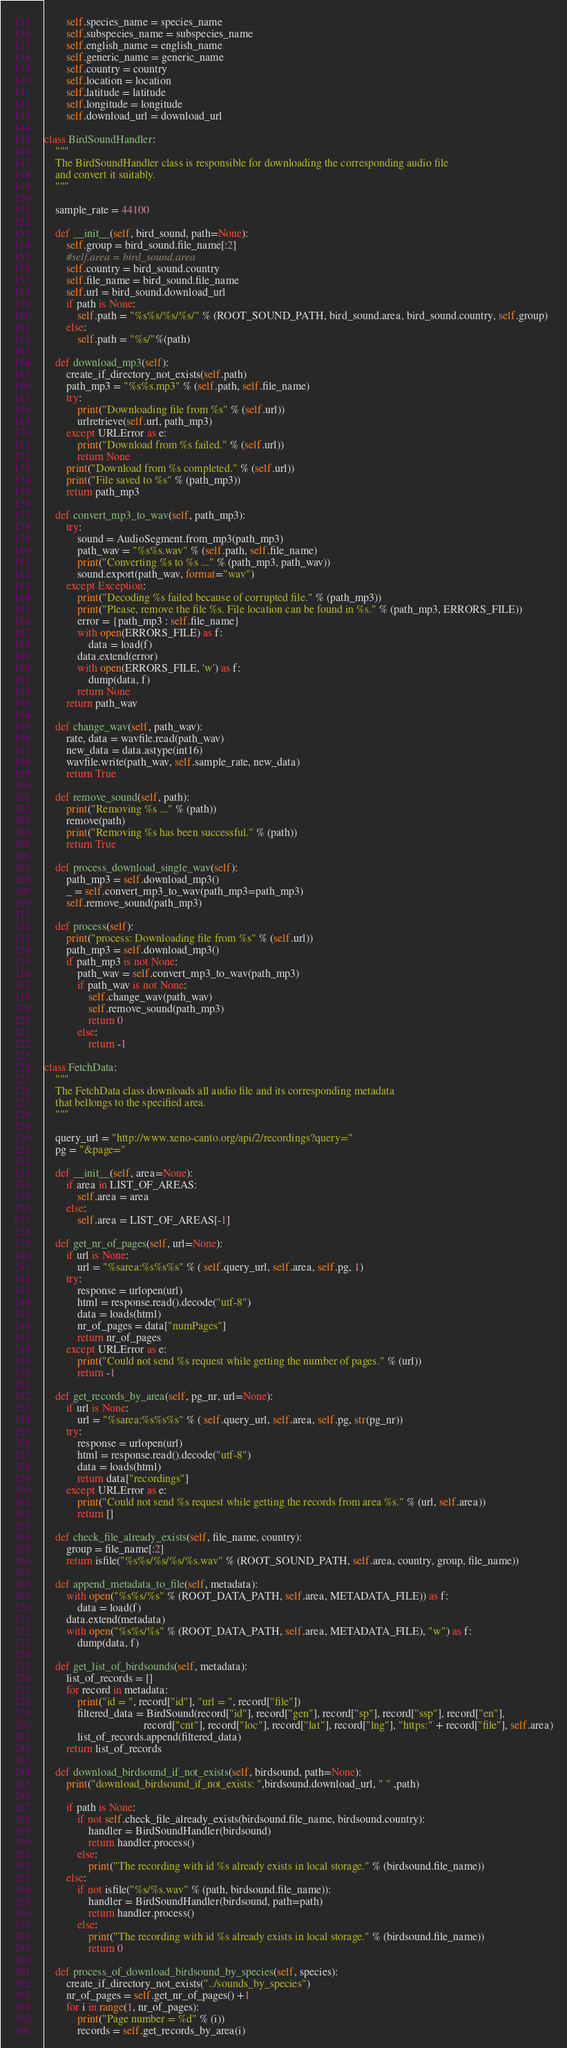<code> <loc_0><loc_0><loc_500><loc_500><_Python_>        self.species_name = species_name
        self.subspecies_name = subspecies_name
        self.english_name = english_name
        self.generic_name = generic_name
        self.country = country
        self.location = location
        self.latitude = latitude
        self.longitude = longitude
        self.download_url = download_url

class BirdSoundHandler:
    """
    The BirdSoundHandler class is responsible for downloading the corresponding audio file
    and convert it suitably.
    """

    sample_rate = 44100

    def __init__(self, bird_sound, path=None):
        self.group = bird_sound.file_name[:2]
        #self.area = bird_sound.area
        self.country = bird_sound.country
        self.file_name = bird_sound.file_name
        self.url = bird_sound.download_url
        if path is None:
            self.path = "%s%s/%s/%s/" % (ROOT_SOUND_PATH, bird_sound.area, bird_sound.country, self.group)
        else:
            self.path = "%s/"%(path)

    def download_mp3(self):
        create_if_directory_not_exists(self.path)
        path_mp3 = "%s%s.mp3" % (self.path, self.file_name)
        try:
            print("Downloading file from %s" % (self.url))
            urlretrieve(self.url, path_mp3)
        except URLError as e:
            print("Download from %s failed." % (self.url))
            return None
        print("Download from %s completed." % (self.url))
        print("File saved to %s" % (path_mp3))
        return path_mp3

    def convert_mp3_to_wav(self, path_mp3):
        try:
            sound = AudioSegment.from_mp3(path_mp3)
            path_wav = "%s%s.wav" % (self.path, self.file_name)
            print("Converting %s to %s ..." % (path_mp3, path_wav))
            sound.export(path_wav, format="wav")
        except Exception:
            print("Decoding %s failed because of corrupted file." % (path_mp3))
            print("Please, remove the file %s. File location can be found in %s." % (path_mp3, ERRORS_FILE))
            error = {path_mp3 : self.file_name}
            with open(ERRORS_FILE) as f:
                data = load(f)
            data.extend(error)
            with open(ERRORS_FILE, 'w') as f:
                dump(data, f)
            return None
        return path_wav

    def change_wav(self, path_wav):
        rate, data = wavfile.read(path_wav)
        new_data = data.astype(int16)
        wavfile.write(path_wav, self.sample_rate, new_data)
        return True

    def remove_sound(self, path):
        print("Removing %s ..." % (path))
        remove(path)
        print("Removing %s has been successful." % (path))
        return True

    def process_download_single_wav(self):
        path_mp3 = self.download_mp3()
        _ = self.convert_mp3_to_wav(path_mp3=path_mp3)
        self.remove_sound(path_mp3)

    def process(self):
        print("process: Downloading file from %s" % (self.url))
        path_mp3 = self.download_mp3()
        if path_mp3 is not None:
            path_wav = self.convert_mp3_to_wav(path_mp3)
            if path_wav is not None:
                self.change_wav(path_wav)
                self.remove_sound(path_mp3)
                return 0
            else:
                return -1

class FetchData:
    """
    The FetchData class downloads all audio file and its corresponding metadata
    that bellongs to the specified area.
    """

    query_url = "http://www.xeno-canto.org/api/2/recordings?query="
    pg = "&page="

    def __init__(self, area=None):
        if area in LIST_OF_AREAS:
            self.area = area
        else:
            self.area = LIST_OF_AREAS[-1]

    def get_nr_of_pages(self, url=None):
        if url is None:
            url = "%sarea:%s%s%s" % ( self.query_url, self.area, self.pg, 1)
        try:
            response = urlopen(url)
            html = response.read().decode("utf-8")
            data = loads(html)
            nr_of_pages = data["numPages"]
            return nr_of_pages
        except URLError as e:
            print("Could not send %s request while getting the number of pages." % (url))
            return -1

    def get_records_by_area(self, pg_nr, url=None):
        if url is None:
            url = "%sarea:%s%s%s" % ( self.query_url, self.area, self.pg, str(pg_nr))
        try:
            response = urlopen(url)
            html = response.read().decode("utf-8")
            data = loads(html)
            return data["recordings"]
        except URLError as e:
            print("Could not send %s request while getting the records from area %s." % (url, self.area))
            return []

    def check_file_already_exists(self, file_name, country):
        group = file_name[:2]
        return isfile("%s%s/%s/%s/%s.wav" % (ROOT_SOUND_PATH, self.area, country, group, file_name))

    def append_metadata_to_file(self, metadata):
        with open("%s%s/%s" % (ROOT_DATA_PATH, self.area, METADATA_FILE)) as f:
            data = load(f)
        data.extend(metadata)
        with open("%s%s/%s" % (ROOT_DATA_PATH, self.area, METADATA_FILE), "w") as f:
            dump(data, f)

    def get_list_of_birdsounds(self, metadata):
        list_of_records = []
        for record in metadata:
            print("id = ", record["id"], "url = ", record["file"])
            filtered_data = BirdSound(record["id"], record["gen"], record["sp"], record["ssp"], record["en"],
                                    record["cnt"], record["loc"], record["lat"], record["lng"], "https:" + record["file"], self.area)
            list_of_records.append(filtered_data)
        return list_of_records

    def download_birdsound_if_not_exists(self, birdsound, path=None):
        print("download_birdsound_if_not_exists: ",birdsound.download_url, " " ,path)

        if path is None:
            if not self.check_file_already_exists(birdsound.file_name, birdsound.country):
                handler = BirdSoundHandler(birdsound)
                return handler.process()
            else:
                print("The recording with id %s already exists in local storage." % (birdsound.file_name))
        else:
            if not isfile("%s/%s.wav" % (path, birdsound.file_name)):
                handler = BirdSoundHandler(birdsound, path=path)
                return handler.process()
            else:
                print("The recording with id %s already exists in local storage." % (birdsound.file_name))
                return 0

    def process_of_download_birdsound_by_species(self, species):
        create_if_directory_not_exists("../sounds_by_species")
        nr_of_pages = self.get_nr_of_pages() +1
        for i in range(1, nr_of_pages):
            print("Page number = %d" % (i))
            records = self.get_records_by_area(i)</code> 